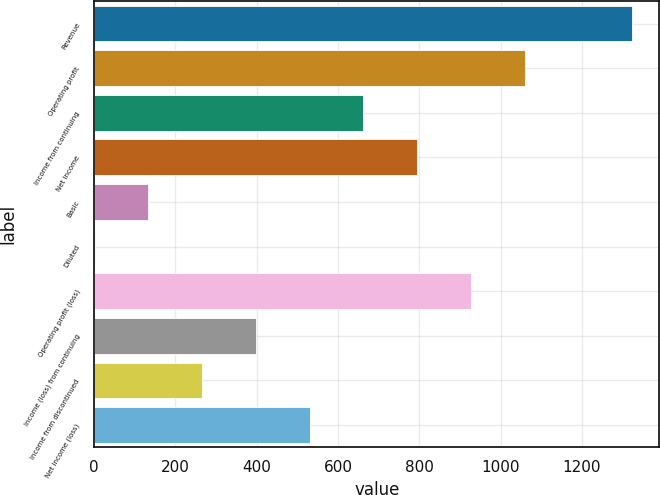Convert chart. <chart><loc_0><loc_0><loc_500><loc_500><bar_chart><fcel>Revenue<fcel>Operating profit<fcel>Income from continuing<fcel>Net income<fcel>Basic<fcel>Diluted<fcel>Operating profit (loss)<fcel>Income (loss) from continuing<fcel>Income from discontinued<fcel>Net income (loss)<nl><fcel>1324<fcel>1059.4<fcel>662.47<fcel>794.78<fcel>133.23<fcel>0.92<fcel>927.09<fcel>397.85<fcel>265.54<fcel>530.16<nl></chart> 